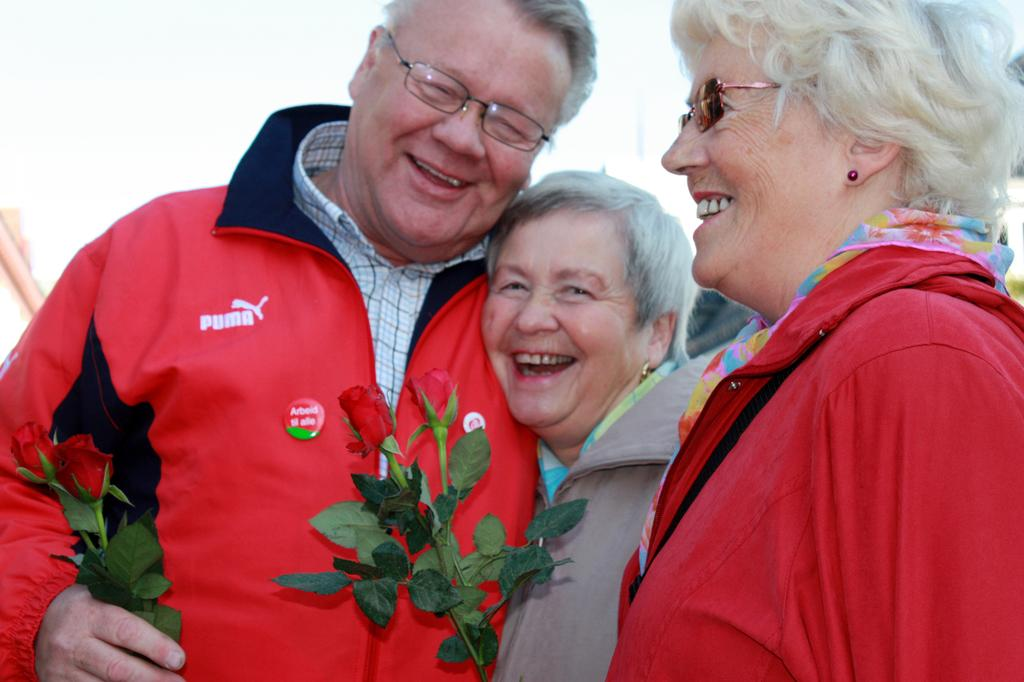What are the people in the image doing? The people in the image are standing in the center and laughing. What can be seen in the image besides the people? There are rose flowers in the image. What is the appearance of the rose flowers? The rose flowers have leaves. What type of invention is being demonstrated by the people in the image? There is no invention being demonstrated in the image; the people are simply standing and laughing. What color is the bear's fur in the image? There are no bears present in the image. 